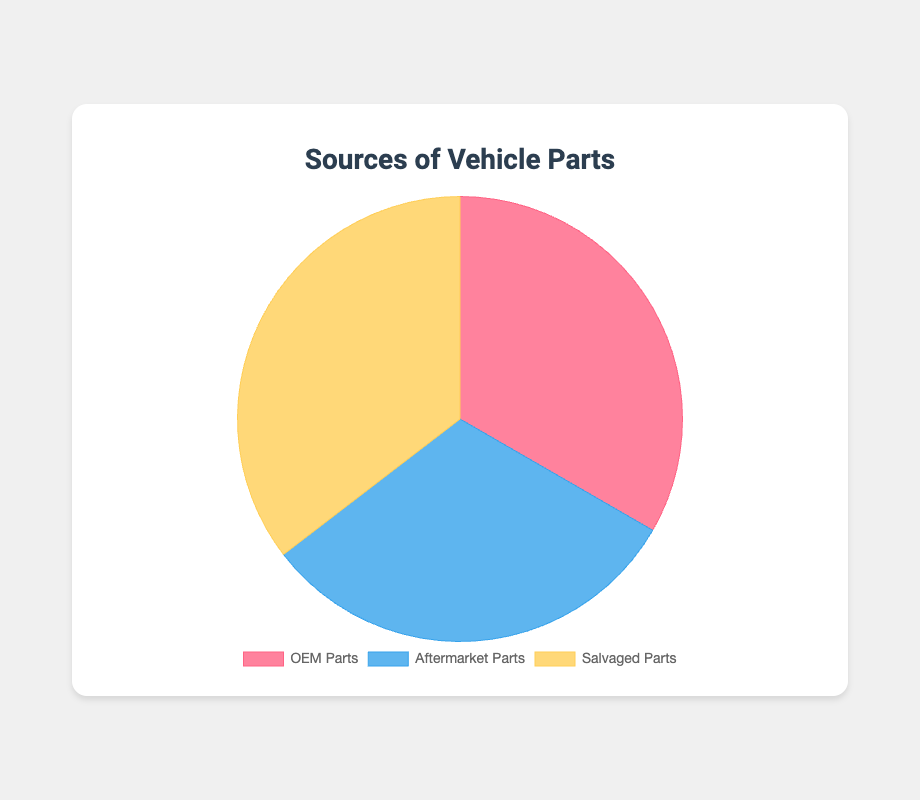What is the total market share of OEM Parts? To find the total market share of OEM Parts, add up the market share percentages from Toyota Genuine Parts (40%), Ford Motorcraft (25%), and Honda Genuine Parts (15%). The sum is 40 + 25 + 15 = 80.
Answer: 80% Which source has the largest market share? Compare the total market shares of OEM Parts (80%), Aftermarket Parts (75%), and Salvaged Parts (85%). Salvaged Parts have the highest total market share of 85%.
Answer: Salvaged Parts What is the difference in market share between the largest and smallest OEM Parts suppliers? The largest OEM Parts supplier is Toyota Genuine Parts with 40%, and the smallest is Honda Genuine Parts with 15%. The difference is 40 - 15 = 25.
Answer: 25% Which supplier has a higher market share, Dorman Products (Aftermarket Parts) or LKQ Corporation (Salvaged Parts)? Dorman Products has a market share of 30%, while LKQ Corporation has a market share of 30%. Both suppliers have the same market share of 30%.
Answer: Both suppliers are equal Are OEM Parts suppliers more dominant than Salvaged Parts suppliers? Sum the market shares of all suppliers for OEM Parts (40+25+15 = 80%) and for Salvaged Parts (35+30+20 = 85%). Salvaged Parts have a slightly higher overall market share than OEM Parts.
Answer: No Which supplier has the smallest market share among all the sources combined? Review the market shares of all suppliers: Toyota Genuine Parts (40%), Ford Motorcraft (25%), Honda Genuine Parts (15%), Dorman Products (30%), Bosch Auto Parts (25%), ACDelco (20%), Pick-n-Pull (35%), LKQ Corporation (30%), Pull-A-Part (20%). The smallest market share is Honda Genuine Parts at 15%.
Answer: Honda Genuine Parts What is the combined market share of Bosch Auto Parts and Ford Motorcraft? Add the market shares of Bosch Auto Parts (25%) and Ford Motorcraft (25%). The combined market share is 25 + 25 = 50.
Answer: 50% Which category has the most evenly distributed market shares among its suppliers? Calculate the range of market share within each category:
- OEM Parts: range = 40 - 15 = 25
- Aftermarket Parts: range = 30 - 20 = 10
- Salvaged Parts: range = 35 - 20 = 15
Aftermarket Parts have the most evenly distributed market shares with the smallest range of 10.
Answer: Aftermarket Parts What is the average market share of all suppliers within the Salvaged Parts source? Add the market shares of suppliers within the Salvaged Parts source: Pick-n-Pull (35%), LKQ Corporation (30%), Pull-A-Part (20%). Sum = 35 + 30 + 20 = 85. The number of suppliers is 3. So, the average is 85 / 3 ≈ 28.33.
Answer: 28.33% 